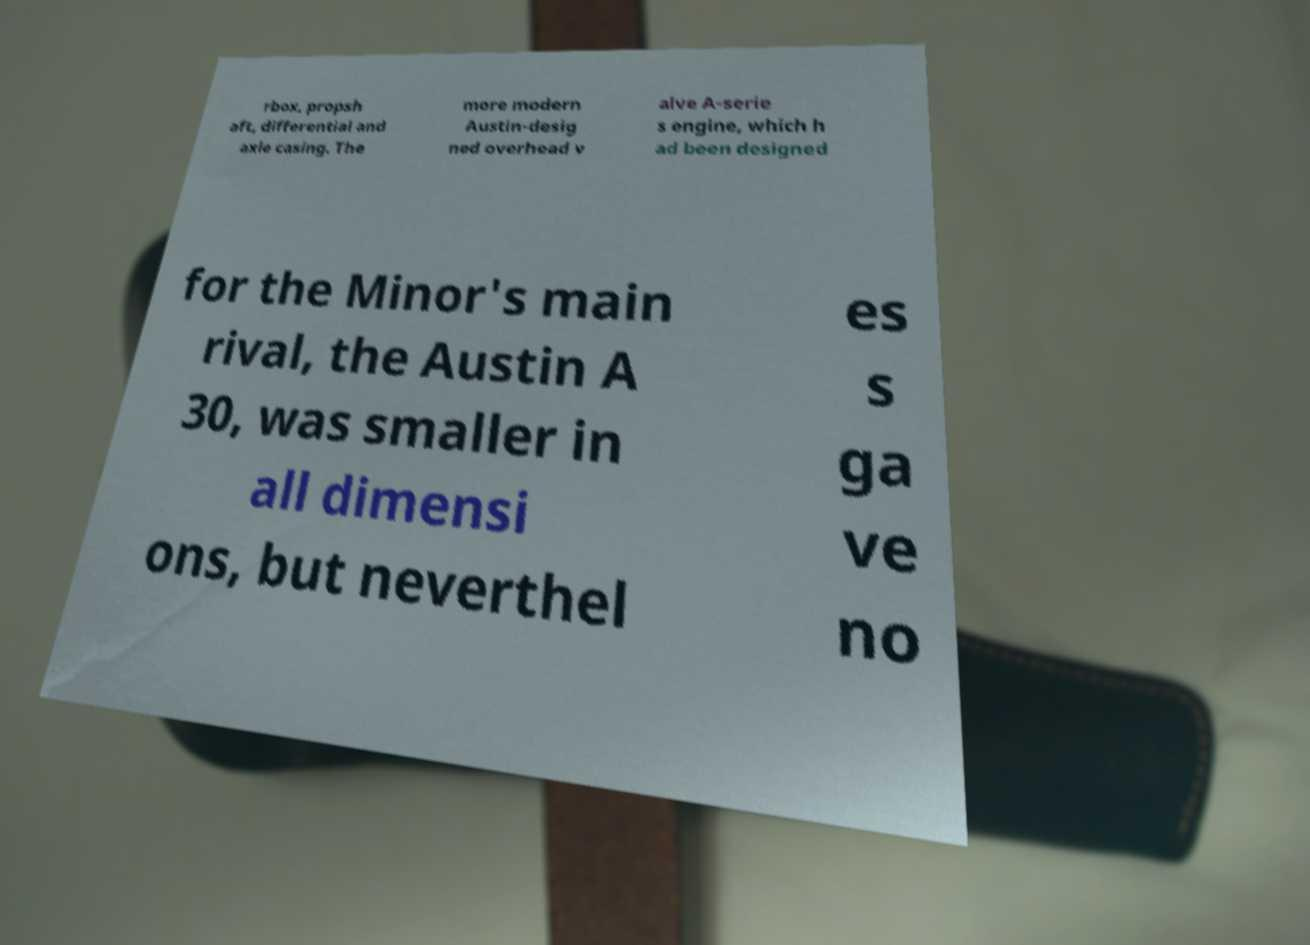For documentation purposes, I need the text within this image transcribed. Could you provide that? rbox, propsh aft, differential and axle casing. The more modern Austin-desig ned overhead v alve A-serie s engine, which h ad been designed for the Minor's main rival, the Austin A 30, was smaller in all dimensi ons, but neverthel es s ga ve no 